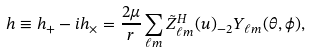Convert formula to latex. <formula><loc_0><loc_0><loc_500><loc_500>h \equiv h _ { + } - i h _ { \times } = \frac { 2 \mu } { r } \sum _ { \ell m } \tilde { Z } ^ { H } _ { \ell m } ( u ) _ { - 2 } Y _ { \ell m } ( \theta , \phi ) ,</formula> 